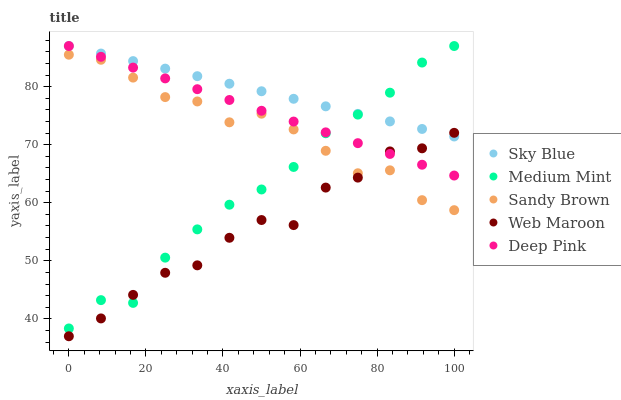Does Web Maroon have the minimum area under the curve?
Answer yes or no. Yes. Does Sky Blue have the maximum area under the curve?
Answer yes or no. Yes. Does Deep Pink have the minimum area under the curve?
Answer yes or no. No. Does Deep Pink have the maximum area under the curve?
Answer yes or no. No. Is Sky Blue the smoothest?
Answer yes or no. Yes. Is Web Maroon the roughest?
Answer yes or no. Yes. Is Deep Pink the smoothest?
Answer yes or no. No. Is Deep Pink the roughest?
Answer yes or no. No. Does Web Maroon have the lowest value?
Answer yes or no. Yes. Does Deep Pink have the lowest value?
Answer yes or no. No. Does Deep Pink have the highest value?
Answer yes or no. Yes. Does Sandy Brown have the highest value?
Answer yes or no. No. Is Sandy Brown less than Sky Blue?
Answer yes or no. Yes. Is Sky Blue greater than Sandy Brown?
Answer yes or no. Yes. Does Sandy Brown intersect Web Maroon?
Answer yes or no. Yes. Is Sandy Brown less than Web Maroon?
Answer yes or no. No. Is Sandy Brown greater than Web Maroon?
Answer yes or no. No. Does Sandy Brown intersect Sky Blue?
Answer yes or no. No. 